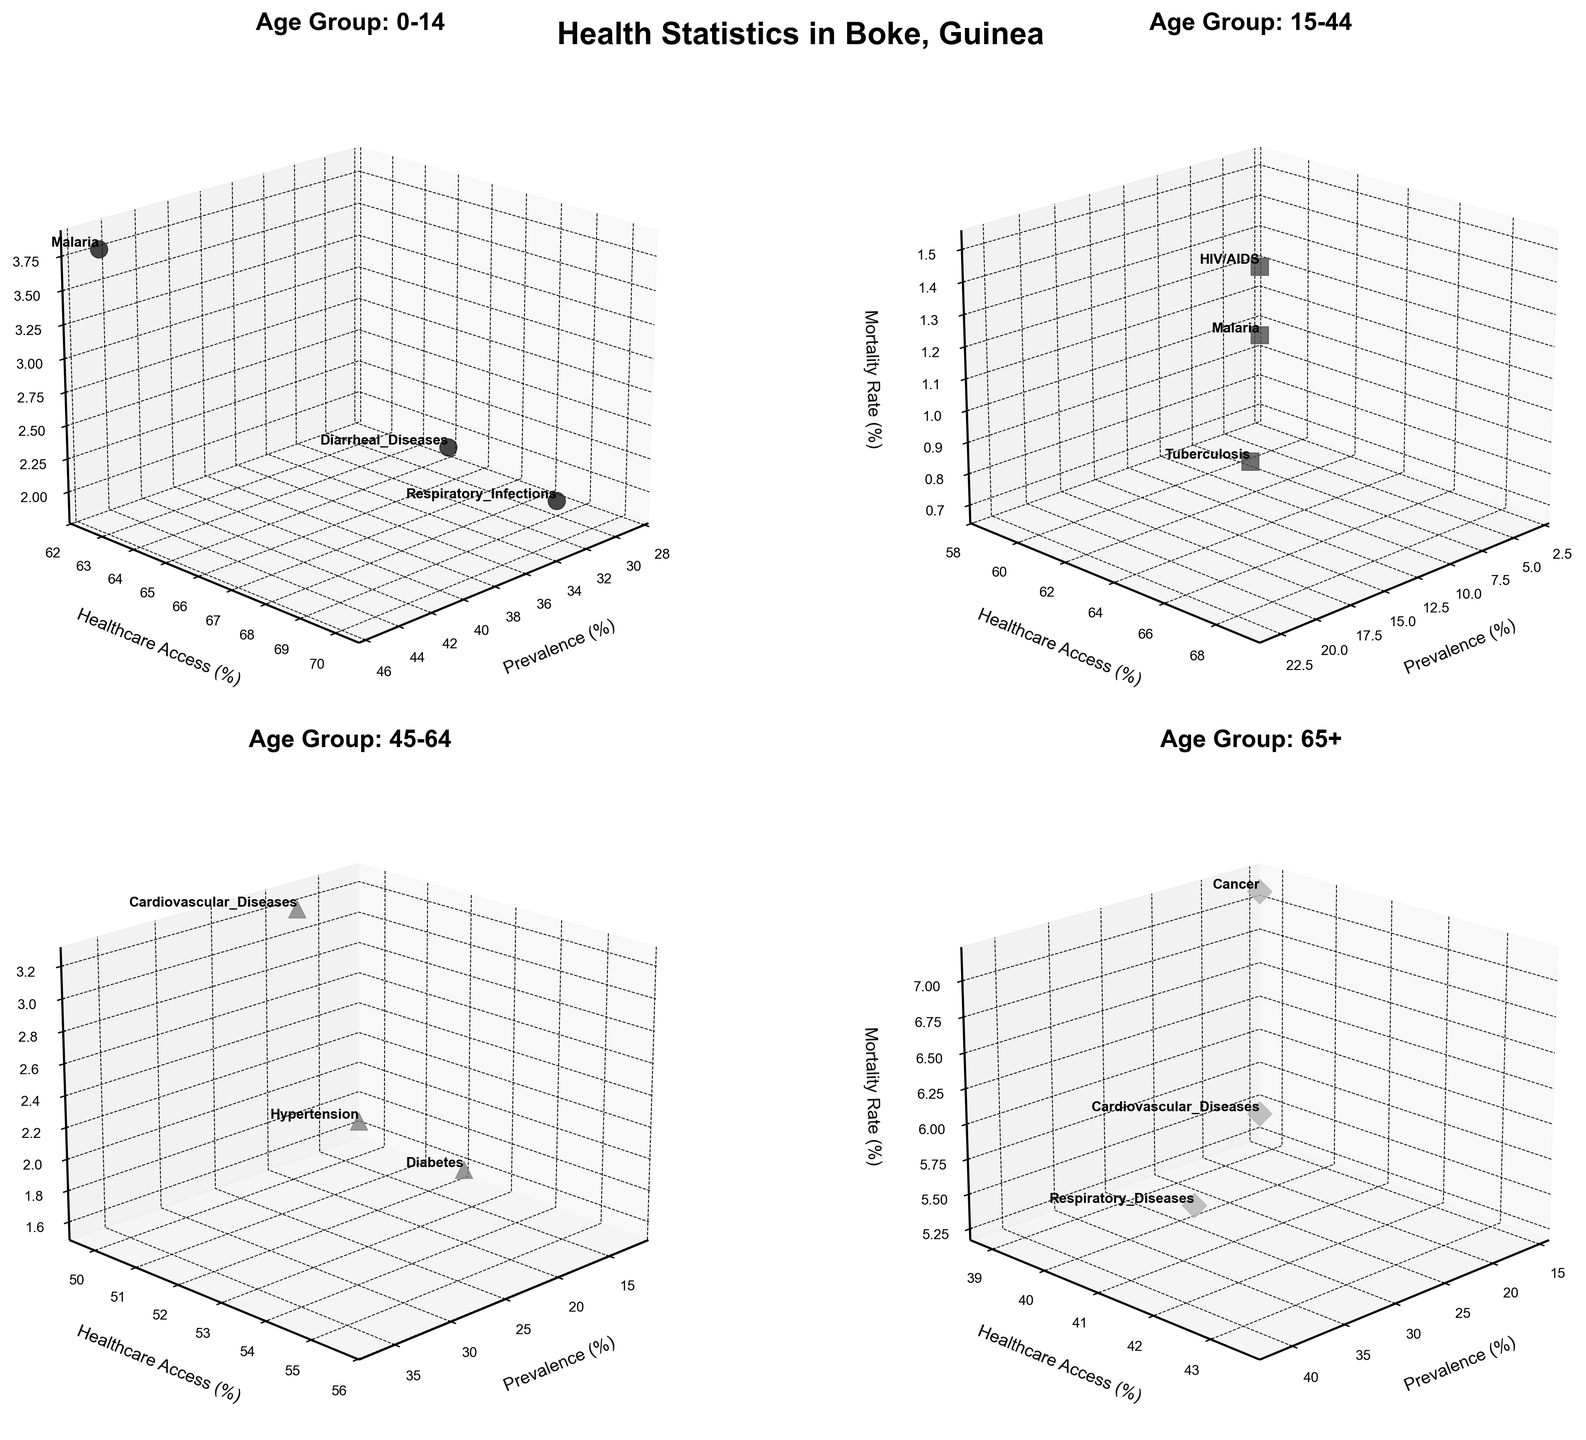What's the title of the figure? The title is usually found at the top of the figure, summarizing the content succinctly.
Answer: Health Statistics in Boke, Guinea What is the age group with the highest mortality rate? By looking at the z-axis (Mortality Rate) across all subplots, we can identify the age group with the highest mortality rate.
Answer: 65+ Which age group and disease combination has the highest healthcare access? By examining the y-axis (Healthcare Access) values across all subplots, we identify the peak value and cross-reference with the age group and disease.
Answer: Age Group: 0-14, Disease: Respiratory Infections In the age group 15-44, which disease has the highest mortality rate? Focus specifically on the subplot for age group 15-44 and compare the mortality rates (z-axis values) for different diseases.
Answer: HIV/AIDS Compare the prevalence of Malaria in the age groups 0-14 and 15-44. Which age group has a higher prevalence? Locate the prevalence (x-axis values) of Malaria in both the 0-14 and 15-44 subplots and compare the numbers.
Answer: 0-14 Among the diseases affecting the 45-64 age group, which has the lowest healthcare access? Review the y-axis (Healthcare Access) values in the 45-64 subplot to find the minimum value and the corresponding disease.
Answer: Cardiovascular Diseases What's the average mortality rate for diseases affecting the 65+ age group? Sum the mortality rates (z-axis values) for all diseases in the 65+ subplot and divide by the number of diseases to find the average. [(6.7 + 5.3 + 7.1) / 3]
Answer: 6.37 For the age group 0-14, is the prevalence of Respiratory Infections greater than Diarrheal Diseases? Compare the x-axis (Prevalence) values for Respiratory Infections and Diarrheal Diseases in the 0-14 subplot.
Answer: Yes Which disease among all age groups has the lowest overall mortality rate? Check all subplots, identify the lowest mortality rate (z-axis values), and note the corresponding disease.
Answer: Tuberculosis (15-44) What are the labels of the three axes in each subplot? Identify the labels on each axis by looking at the text near the respective axis lines on any of the subplots.
Answer: Prevalence (%), Healthcare Access (%), Mortality Rate (%) 